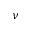<formula> <loc_0><loc_0><loc_500><loc_500>\nu</formula> 